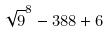<formula> <loc_0><loc_0><loc_500><loc_500>\sqrt { 9 } ^ { 8 } - 3 8 8 + 6</formula> 